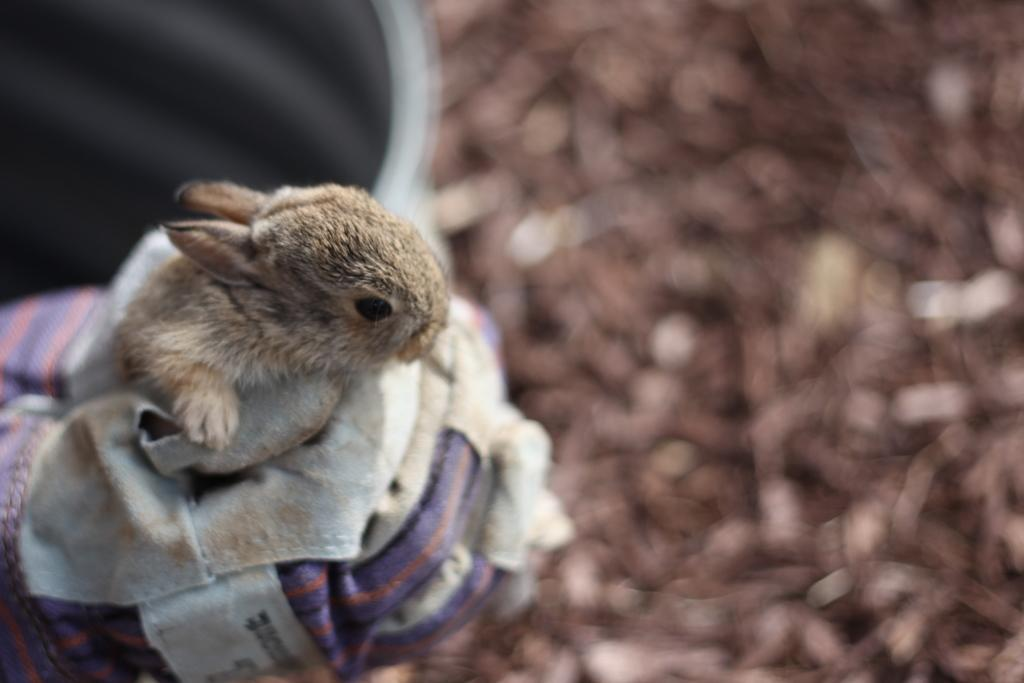What type of living creature is in the image? There is an animal in the image. What material is present in the image? There is cloth in the image. What else can be seen in the image besides the animal and cloth? There are some objects in the image. Can you describe the background of the image? The background of the image is blurry. How does the animal run away from the rainstorm in the image? There is no rainstorm present in the image, and the animal is not running. 